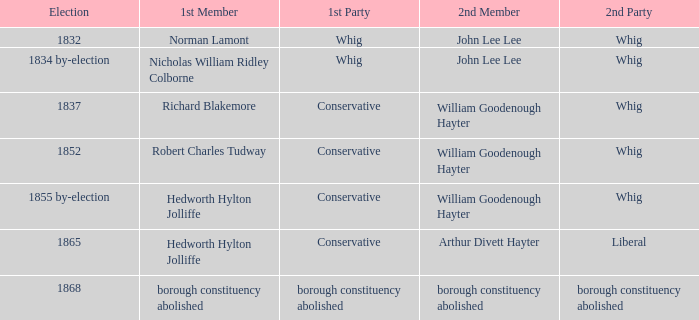Who's the traditionalist 1st participant in the election of 1852? Robert Charles Tudway. Parse the full table. {'header': ['Election', '1st Member', '1st Party', '2nd Member', '2nd Party'], 'rows': [['1832', 'Norman Lamont', 'Whig', 'John Lee Lee', 'Whig'], ['1834 by-election', 'Nicholas William Ridley Colborne', 'Whig', 'John Lee Lee', 'Whig'], ['1837', 'Richard Blakemore', 'Conservative', 'William Goodenough Hayter', 'Whig'], ['1852', 'Robert Charles Tudway', 'Conservative', 'William Goodenough Hayter', 'Whig'], ['1855 by-election', 'Hedworth Hylton Jolliffe', 'Conservative', 'William Goodenough Hayter', 'Whig'], ['1865', 'Hedworth Hylton Jolliffe', 'Conservative', 'Arthur Divett Hayter', 'Liberal'], ['1868', 'borough constituency abolished', 'borough constituency abolished', 'borough constituency abolished', 'borough constituency abolished']]} 